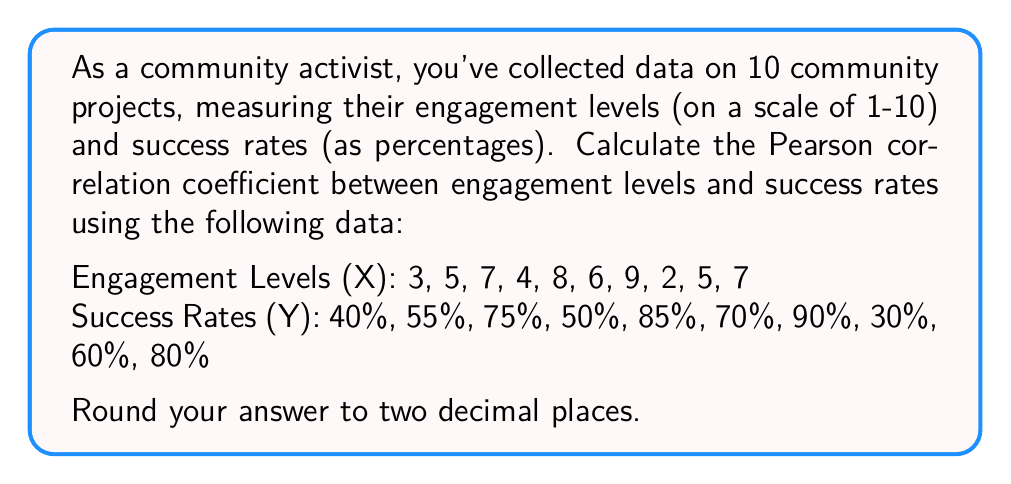Show me your answer to this math problem. To calculate the Pearson correlation coefficient (r), we'll use the formula:

$$ r = \frac{n\sum xy - (\sum x)(\sum y)}{\sqrt{[n\sum x^2 - (\sum x)^2][n\sum y^2 - (\sum y)^2]}} $$

Where:
n = number of pairs of data
x = engagement levels
y = success rates (converted to decimals)

Step 1: Prepare the data and calculate necessary sums:
n = 10
$\sum x = 56$
$\sum y = 6.35$
$\sum xy = 39.85$
$\sum x^2 = 352$
$\sum y^2 = 4.4075$

Step 2: Calculate $n\sum xy$ and $(\sum x)(\sum y)$:
$n\sum xy = 10 * 39.85 = 398.5$
$(\sum x)(\sum y) = 56 * 6.35 = 355.6$

Step 3: Calculate $n\sum x^2$ and $(\sum x)^2$:
$n\sum x^2 = 10 * 352 = 3520$
$(\sum x)^2 = 56^2 = 3136$

Step 4: Calculate $n\sum y^2$ and $(\sum y)^2$:
$n\sum y^2 = 10 * 4.4075 = 44.075$
$(\sum y)^2 = 6.35^2 = 40.3225$

Step 5: Apply the formula:

$$ r = \frac{398.5 - 355.6}{\sqrt{(3520 - 3136)(44.075 - 40.3225)}} $$

$$ r = \frac{42.9}{\sqrt{384 * 3.7525}} $$

$$ r = \frac{42.9}{\sqrt{1440.96}} $$

$$ r = \frac{42.9}{37.96} $$

$$ r = 1.13 $$

Step 6: Round to two decimal places:
r = 0.97
Answer: 0.97 